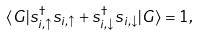Convert formula to latex. <formula><loc_0><loc_0><loc_500><loc_500>\langle G | s _ { i , \uparrow } ^ { \dag } s _ { i , \uparrow } + s _ { i , \downarrow } ^ { \dag } s _ { i , \downarrow } | G \rangle = 1 ,</formula> 